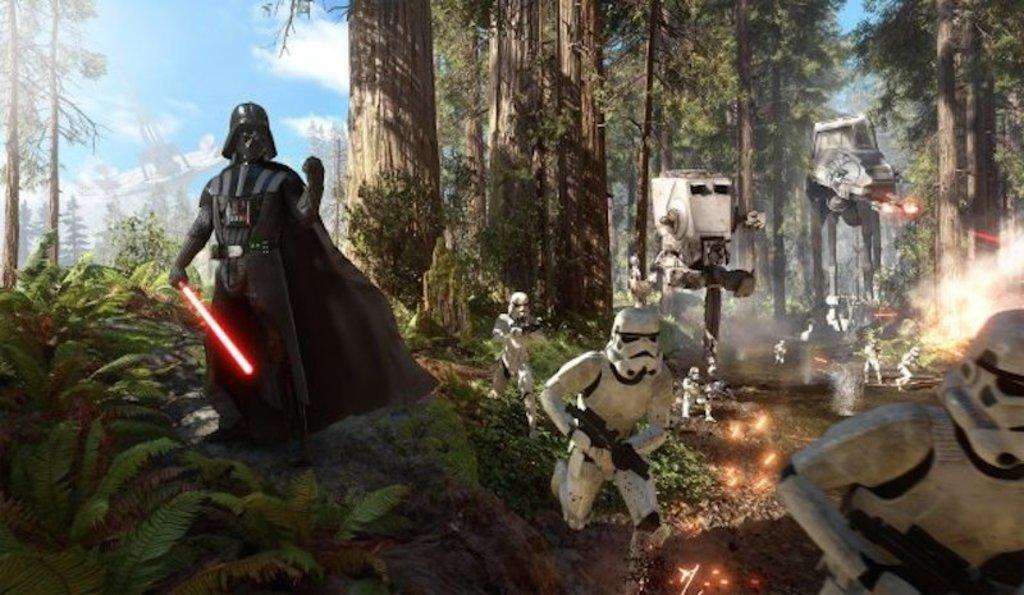How would you summarize this image in a sentence or two? This is an animated picture. In the foreground of the picture there are robots holding swords and guns. In the background there are trees. On the left there are plants. Sky is sunny. 